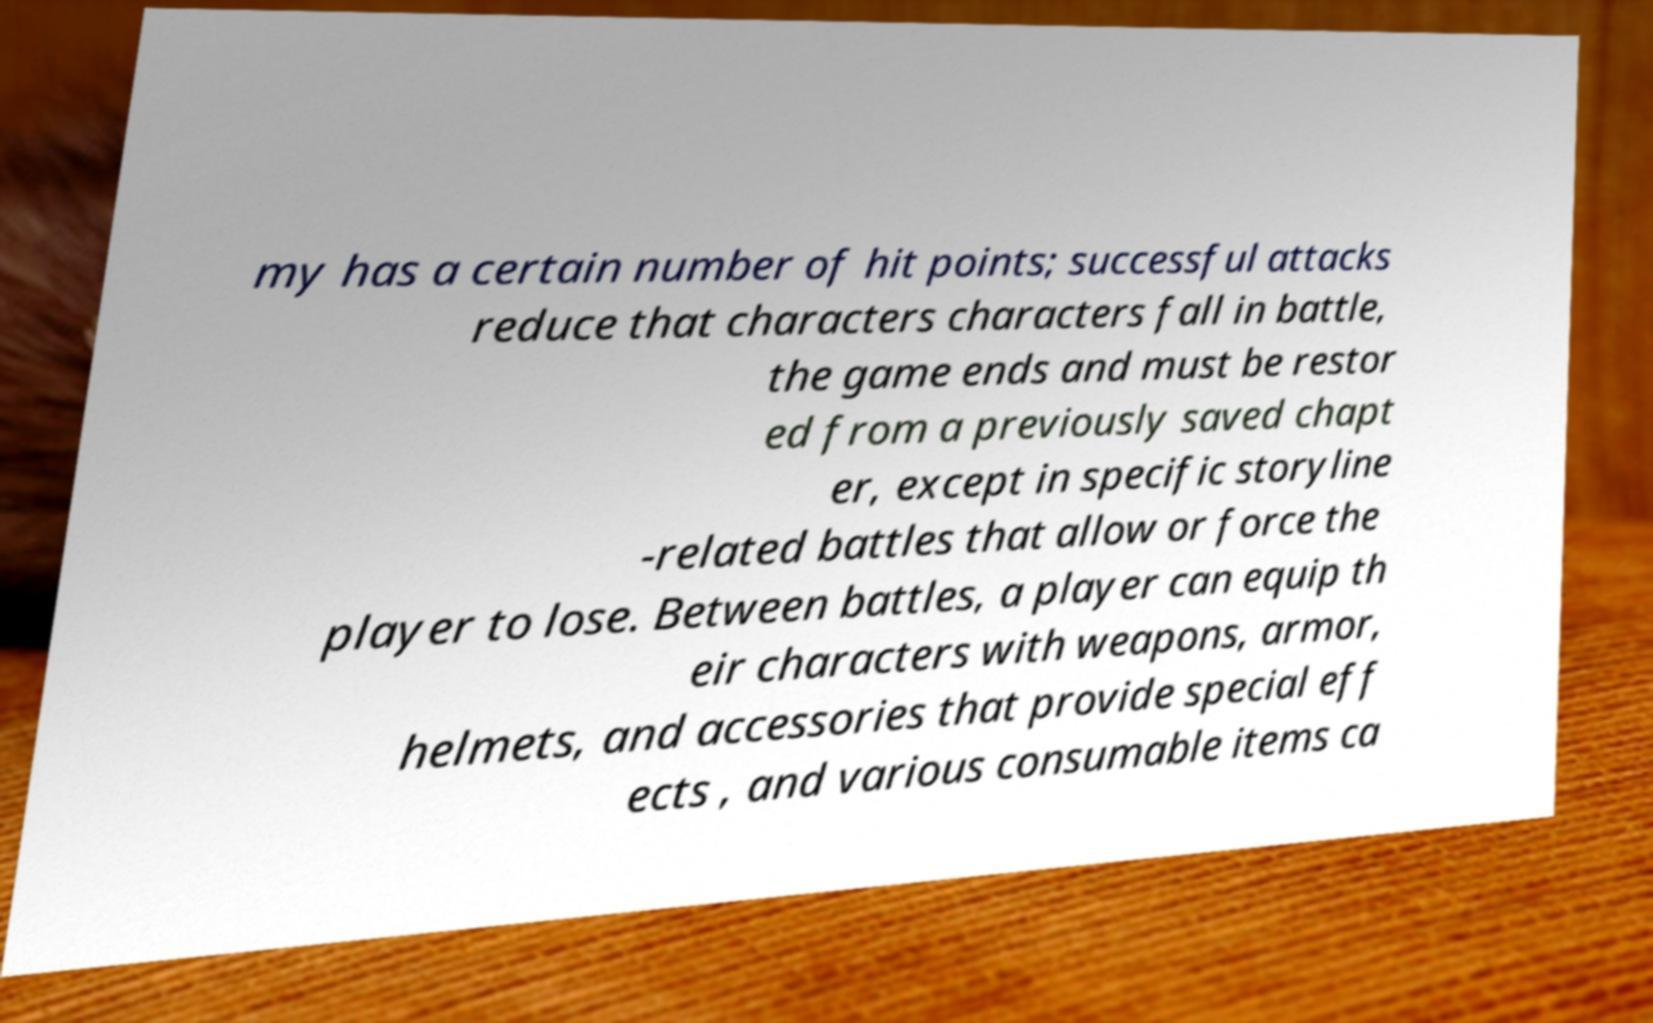Please identify and transcribe the text found in this image. my has a certain number of hit points; successful attacks reduce that characters characters fall in battle, the game ends and must be restor ed from a previously saved chapt er, except in specific storyline -related battles that allow or force the player to lose. Between battles, a player can equip th eir characters with weapons, armor, helmets, and accessories that provide special eff ects , and various consumable items ca 